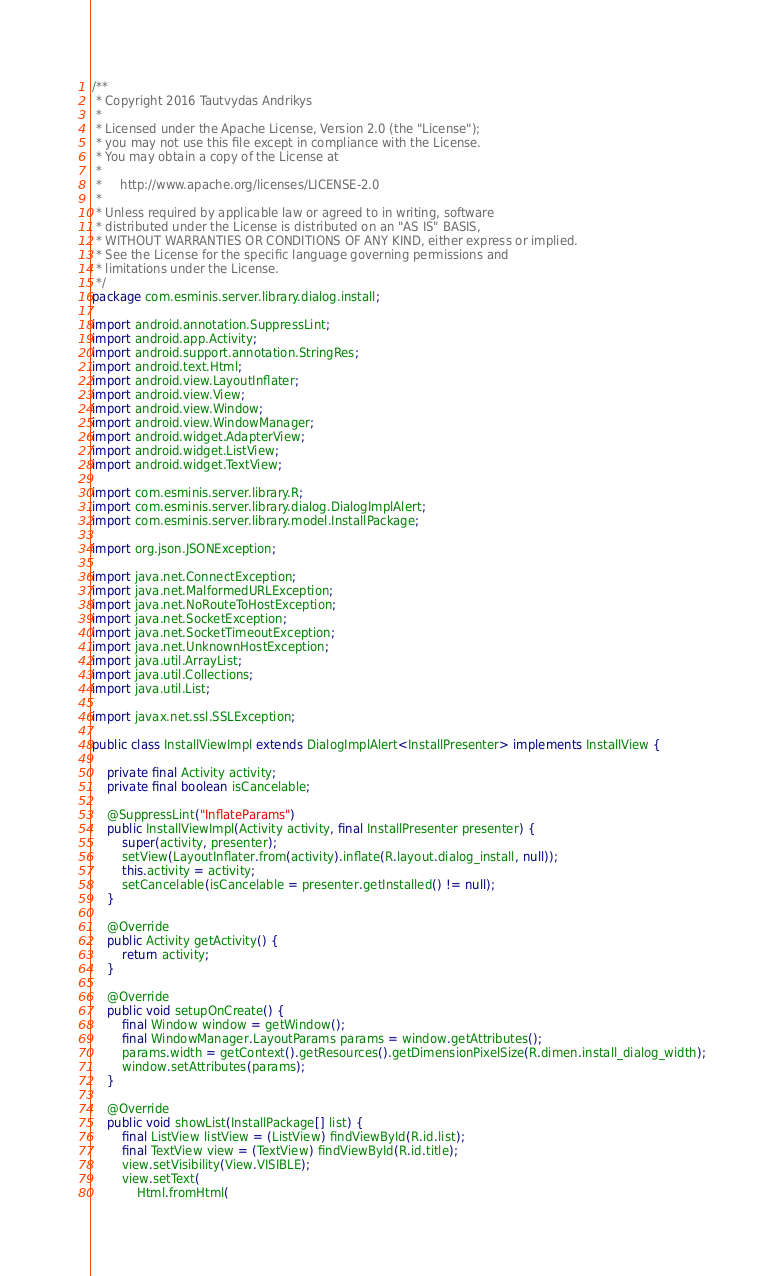Convert code to text. <code><loc_0><loc_0><loc_500><loc_500><_Java_>/**
 * Copyright 2016 Tautvydas Andrikys
 *
 * Licensed under the Apache License, Version 2.0 (the "License");
 * you may not use this file except in compliance with the License.
 * You may obtain a copy of the License at
 *
 *     http://www.apache.org/licenses/LICENSE-2.0
 *
 * Unless required by applicable law or agreed to in writing, software
 * distributed under the License is distributed on an "AS IS" BASIS,
 * WITHOUT WARRANTIES OR CONDITIONS OF ANY KIND, either express or implied.
 * See the License for the specific language governing permissions and
 * limitations under the License.
 */
package com.esminis.server.library.dialog.install;

import android.annotation.SuppressLint;
import android.app.Activity;
import android.support.annotation.StringRes;
import android.text.Html;
import android.view.LayoutInflater;
import android.view.View;
import android.view.Window;
import android.view.WindowManager;
import android.widget.AdapterView;
import android.widget.ListView;
import android.widget.TextView;

import com.esminis.server.library.R;
import com.esminis.server.library.dialog.DialogImplAlert;
import com.esminis.server.library.model.InstallPackage;

import org.json.JSONException;

import java.net.ConnectException;
import java.net.MalformedURLException;
import java.net.NoRouteToHostException;
import java.net.SocketException;
import java.net.SocketTimeoutException;
import java.net.UnknownHostException;
import java.util.ArrayList;
import java.util.Collections;
import java.util.List;

import javax.net.ssl.SSLException;

public class InstallViewImpl extends DialogImplAlert<InstallPresenter> implements InstallView {

	private final Activity activity;
	private final boolean isCancelable;

	@SuppressLint("InflateParams")
	public InstallViewImpl(Activity activity, final InstallPresenter presenter) {
		super(activity, presenter);
		setView(LayoutInflater.from(activity).inflate(R.layout.dialog_install, null));
		this.activity = activity;
		setCancelable(isCancelable = presenter.getInstalled() != null);
	}

	@Override
	public Activity getActivity() {
		return activity;
	}

	@Override
	public void setupOnCreate() {
		final Window window = getWindow();
		final WindowManager.LayoutParams params = window.getAttributes();
		params.width = getContext().getResources().getDimensionPixelSize(R.dimen.install_dialog_width);
		window.setAttributes(params);
	}

	@Override
	public void showList(InstallPackage[] list) {
		final ListView listView = (ListView) findViewById(R.id.list);
		final TextView view = (TextView) findViewById(R.id.title);
		view.setVisibility(View.VISIBLE);
		view.setText(
			Html.fromHtml(</code> 